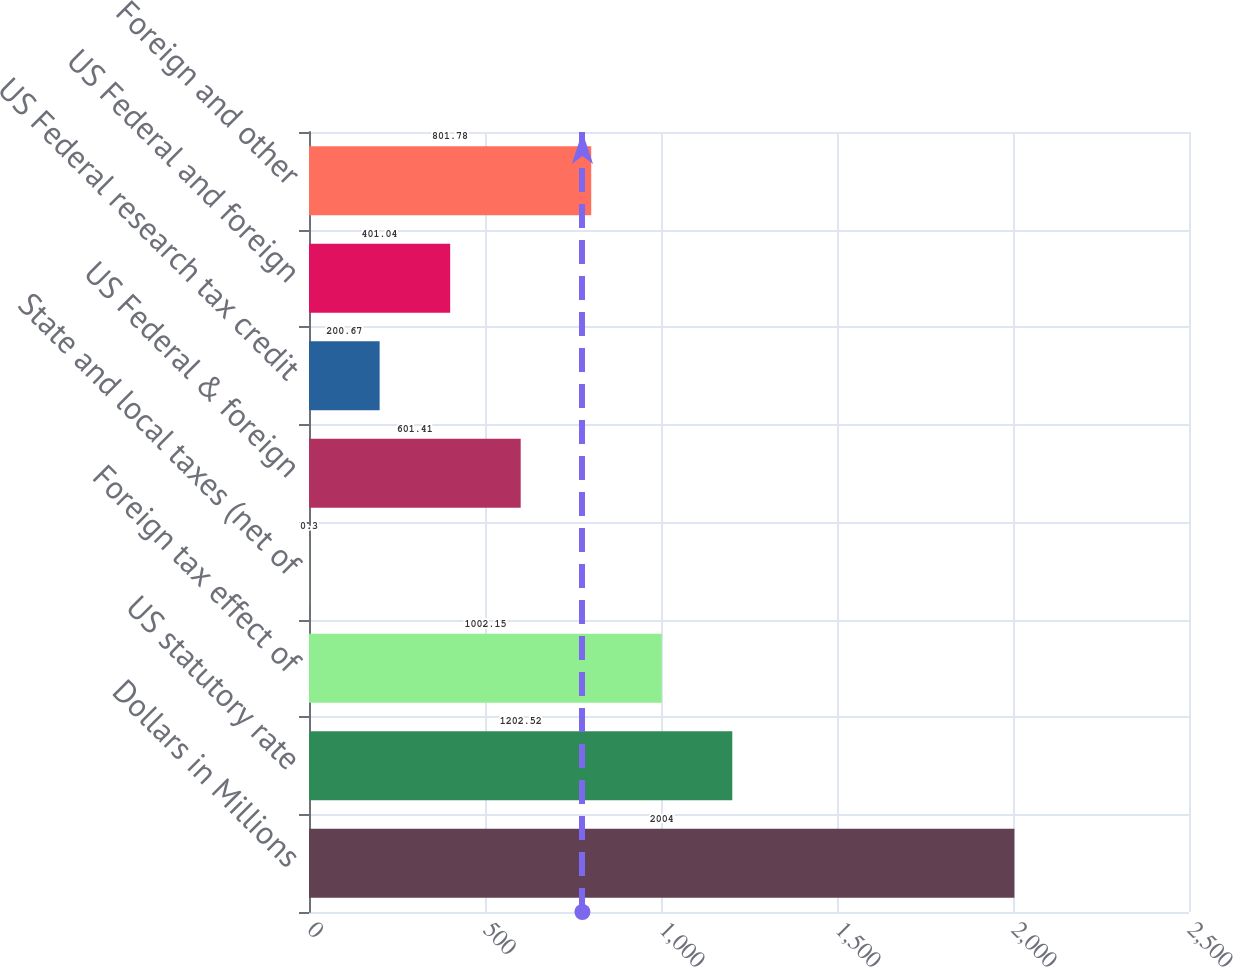Convert chart. <chart><loc_0><loc_0><loc_500><loc_500><bar_chart><fcel>Dollars in Millions<fcel>US statutory rate<fcel>Foreign tax effect of<fcel>State and local taxes (net of<fcel>US Federal & foreign<fcel>US Federal research tax credit<fcel>US Federal and foreign<fcel>Foreign and other<nl><fcel>2004<fcel>1202.52<fcel>1002.15<fcel>0.3<fcel>601.41<fcel>200.67<fcel>401.04<fcel>801.78<nl></chart> 